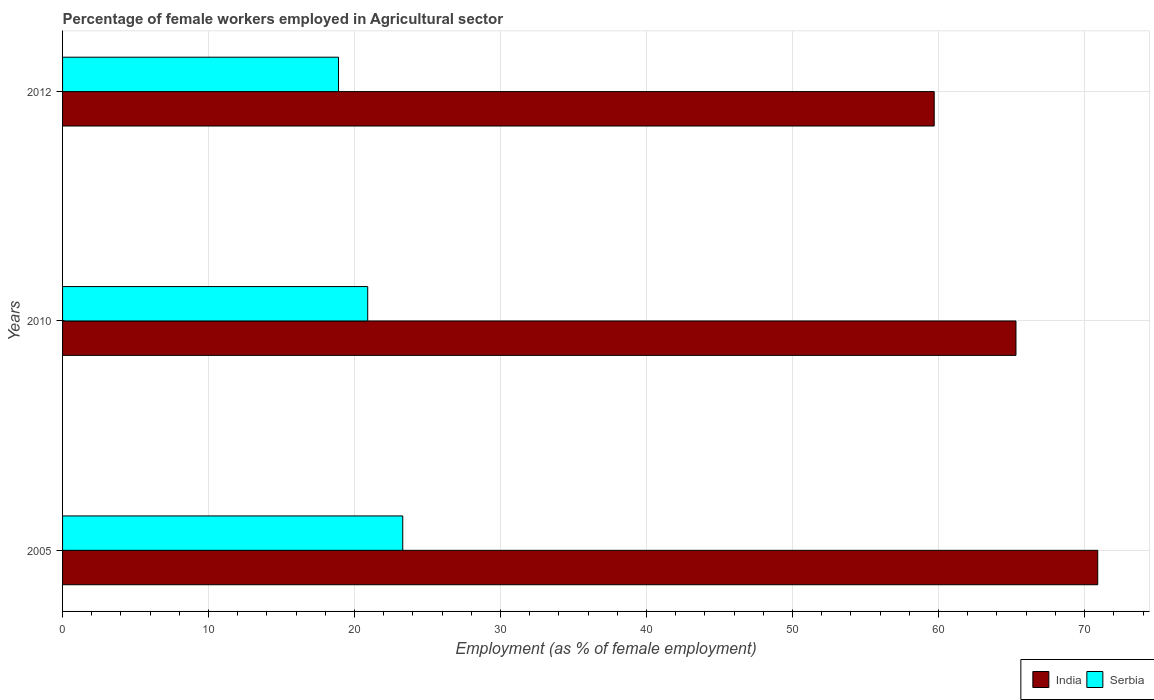How many different coloured bars are there?
Your answer should be compact. 2. Are the number of bars per tick equal to the number of legend labels?
Your answer should be compact. Yes. What is the label of the 3rd group of bars from the top?
Give a very brief answer. 2005. In how many cases, is the number of bars for a given year not equal to the number of legend labels?
Offer a terse response. 0. What is the percentage of females employed in Agricultural sector in India in 2012?
Provide a short and direct response. 59.7. Across all years, what is the maximum percentage of females employed in Agricultural sector in Serbia?
Your answer should be compact. 23.3. Across all years, what is the minimum percentage of females employed in Agricultural sector in Serbia?
Your answer should be compact. 18.9. What is the total percentage of females employed in Agricultural sector in Serbia in the graph?
Provide a succinct answer. 63.1. What is the difference between the percentage of females employed in Agricultural sector in India in 2005 and that in 2010?
Offer a very short reply. 5.6. What is the difference between the percentage of females employed in Agricultural sector in India in 2005 and the percentage of females employed in Agricultural sector in Serbia in 2012?
Offer a terse response. 52. What is the average percentage of females employed in Agricultural sector in India per year?
Offer a very short reply. 65.3. In the year 2005, what is the difference between the percentage of females employed in Agricultural sector in India and percentage of females employed in Agricultural sector in Serbia?
Your answer should be compact. 47.6. In how many years, is the percentage of females employed in Agricultural sector in India greater than 2 %?
Offer a terse response. 3. What is the ratio of the percentage of females employed in Agricultural sector in Serbia in 2005 to that in 2012?
Make the answer very short. 1.23. Is the percentage of females employed in Agricultural sector in Serbia in 2010 less than that in 2012?
Your response must be concise. No. Is the difference between the percentage of females employed in Agricultural sector in India in 2005 and 2012 greater than the difference between the percentage of females employed in Agricultural sector in Serbia in 2005 and 2012?
Keep it short and to the point. Yes. What is the difference between the highest and the second highest percentage of females employed in Agricultural sector in India?
Your answer should be compact. 5.6. What is the difference between the highest and the lowest percentage of females employed in Agricultural sector in India?
Make the answer very short. 11.2. What does the 1st bar from the top in 2005 represents?
Ensure brevity in your answer.  Serbia. What does the 2nd bar from the bottom in 2012 represents?
Keep it short and to the point. Serbia. How many bars are there?
Offer a terse response. 6. Are all the bars in the graph horizontal?
Give a very brief answer. Yes. Does the graph contain any zero values?
Keep it short and to the point. No. How are the legend labels stacked?
Provide a succinct answer. Horizontal. What is the title of the graph?
Your answer should be very brief. Percentage of female workers employed in Agricultural sector. What is the label or title of the X-axis?
Offer a terse response. Employment (as % of female employment). What is the Employment (as % of female employment) of India in 2005?
Make the answer very short. 70.9. What is the Employment (as % of female employment) of Serbia in 2005?
Provide a succinct answer. 23.3. What is the Employment (as % of female employment) of India in 2010?
Offer a very short reply. 65.3. What is the Employment (as % of female employment) of Serbia in 2010?
Offer a terse response. 20.9. What is the Employment (as % of female employment) in India in 2012?
Offer a very short reply. 59.7. What is the Employment (as % of female employment) of Serbia in 2012?
Provide a succinct answer. 18.9. Across all years, what is the maximum Employment (as % of female employment) in India?
Keep it short and to the point. 70.9. Across all years, what is the maximum Employment (as % of female employment) in Serbia?
Provide a short and direct response. 23.3. Across all years, what is the minimum Employment (as % of female employment) in India?
Make the answer very short. 59.7. Across all years, what is the minimum Employment (as % of female employment) in Serbia?
Make the answer very short. 18.9. What is the total Employment (as % of female employment) of India in the graph?
Provide a short and direct response. 195.9. What is the total Employment (as % of female employment) in Serbia in the graph?
Give a very brief answer. 63.1. What is the difference between the Employment (as % of female employment) in India in 2005 and that in 2010?
Offer a very short reply. 5.6. What is the difference between the Employment (as % of female employment) in India in 2005 and that in 2012?
Provide a short and direct response. 11.2. What is the difference between the Employment (as % of female employment) in Serbia in 2010 and that in 2012?
Offer a very short reply. 2. What is the difference between the Employment (as % of female employment) of India in 2005 and the Employment (as % of female employment) of Serbia in 2012?
Provide a short and direct response. 52. What is the difference between the Employment (as % of female employment) of India in 2010 and the Employment (as % of female employment) of Serbia in 2012?
Offer a very short reply. 46.4. What is the average Employment (as % of female employment) of India per year?
Your response must be concise. 65.3. What is the average Employment (as % of female employment) of Serbia per year?
Your answer should be very brief. 21.03. In the year 2005, what is the difference between the Employment (as % of female employment) in India and Employment (as % of female employment) in Serbia?
Offer a terse response. 47.6. In the year 2010, what is the difference between the Employment (as % of female employment) of India and Employment (as % of female employment) of Serbia?
Provide a short and direct response. 44.4. In the year 2012, what is the difference between the Employment (as % of female employment) in India and Employment (as % of female employment) in Serbia?
Provide a short and direct response. 40.8. What is the ratio of the Employment (as % of female employment) of India in 2005 to that in 2010?
Your answer should be very brief. 1.09. What is the ratio of the Employment (as % of female employment) in Serbia in 2005 to that in 2010?
Offer a terse response. 1.11. What is the ratio of the Employment (as % of female employment) in India in 2005 to that in 2012?
Your answer should be compact. 1.19. What is the ratio of the Employment (as % of female employment) of Serbia in 2005 to that in 2012?
Provide a succinct answer. 1.23. What is the ratio of the Employment (as % of female employment) in India in 2010 to that in 2012?
Ensure brevity in your answer.  1.09. What is the ratio of the Employment (as % of female employment) in Serbia in 2010 to that in 2012?
Offer a very short reply. 1.11. What is the difference between the highest and the second highest Employment (as % of female employment) in Serbia?
Give a very brief answer. 2.4. 